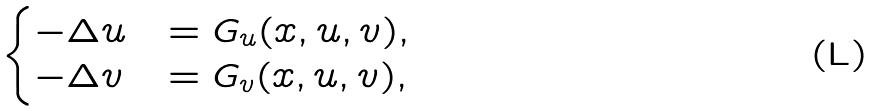<formula> <loc_0><loc_0><loc_500><loc_500>\begin{cases} - \Delta u & = G _ { u } ( x , u , v ) , \\ - \Delta v & = G _ { v } ( x , u , v ) , \end{cases}</formula> 